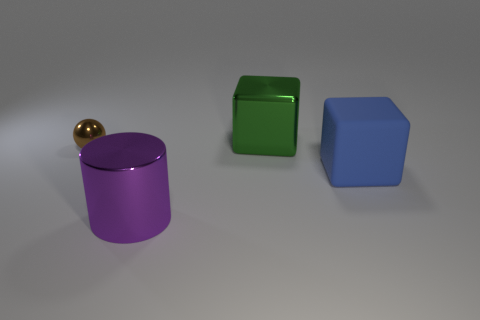Are there any other things that have the same material as the blue thing?
Ensure brevity in your answer.  No. Is there anything else that has the same size as the brown metallic object?
Ensure brevity in your answer.  No. There is a large object that is both behind the big purple metallic thing and in front of the green metal block; what is its shape?
Provide a short and direct response. Cube. What is the material of the object in front of the large cube that is to the right of the green object?
Provide a succinct answer. Metal. Are there more big blue blocks than tiny blue shiny blocks?
Give a very brief answer. Yes. There is another cube that is the same size as the green shiny cube; what material is it?
Your response must be concise. Rubber. Are the purple object and the brown object made of the same material?
Your answer should be compact. Yes. How many small brown things have the same material as the purple cylinder?
Offer a very short reply. 1. What number of objects are either large cubes that are behind the small ball or large objects that are behind the small brown object?
Provide a succinct answer. 1. Is the number of things that are on the left side of the large purple metallic object greater than the number of small balls behind the green object?
Make the answer very short. Yes. 